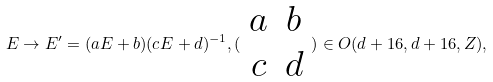<formula> <loc_0><loc_0><loc_500><loc_500>E \rightarrow E ^ { \prime } = ( a E + b ) ( c E + d ) ^ { - 1 } , ( \begin{array} { c c } a & b \\ c & d \end{array} ) \in O ( d + 1 6 , d + 1 6 , Z ) ,</formula> 